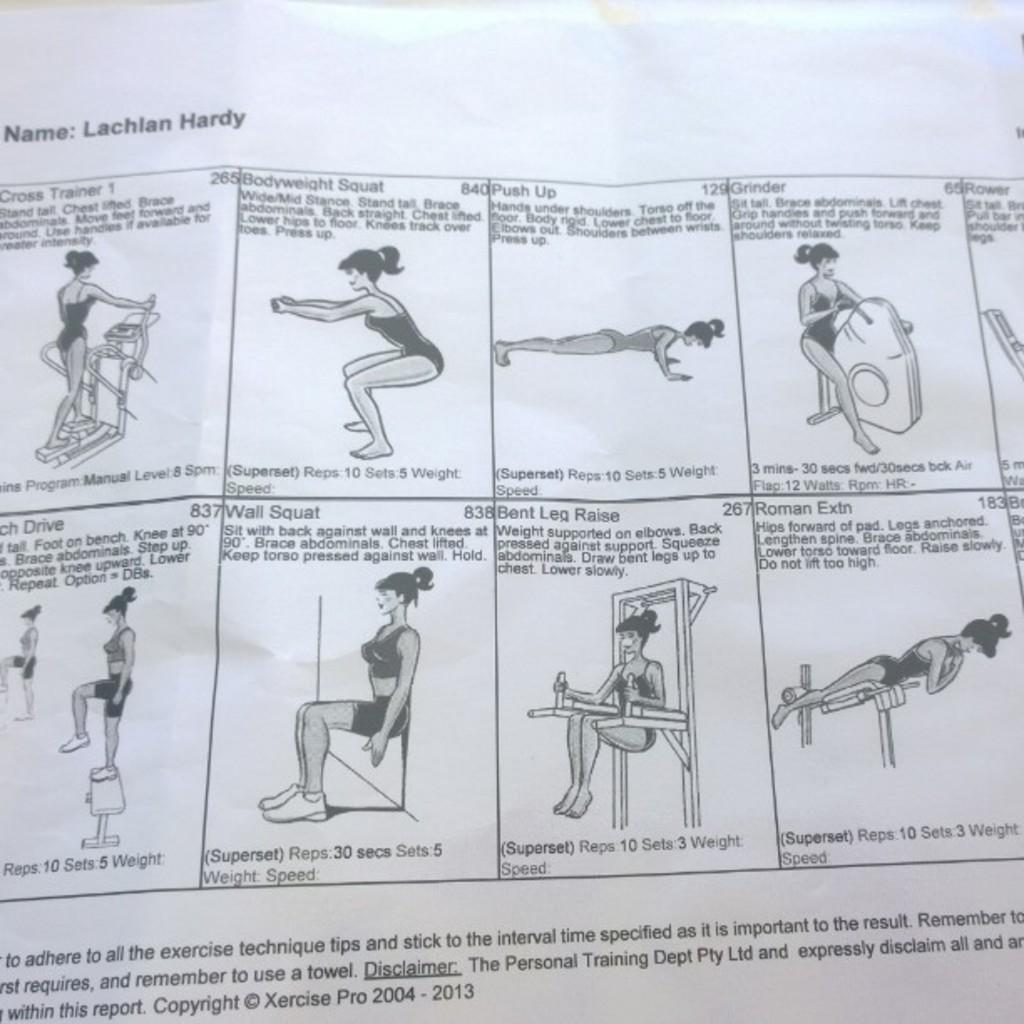Who is the main subject in the image? There is a lady in the image. What is the lady doing in the image? The lady is doing exercise in different positions. Can you describe anything else visible in the image? There is text visible in the background of the image. How many kittens are playing with the sun in the image? There are no kittens or sun present in the image. What type of waste can be seen in the image? There is no waste visible in the image. 